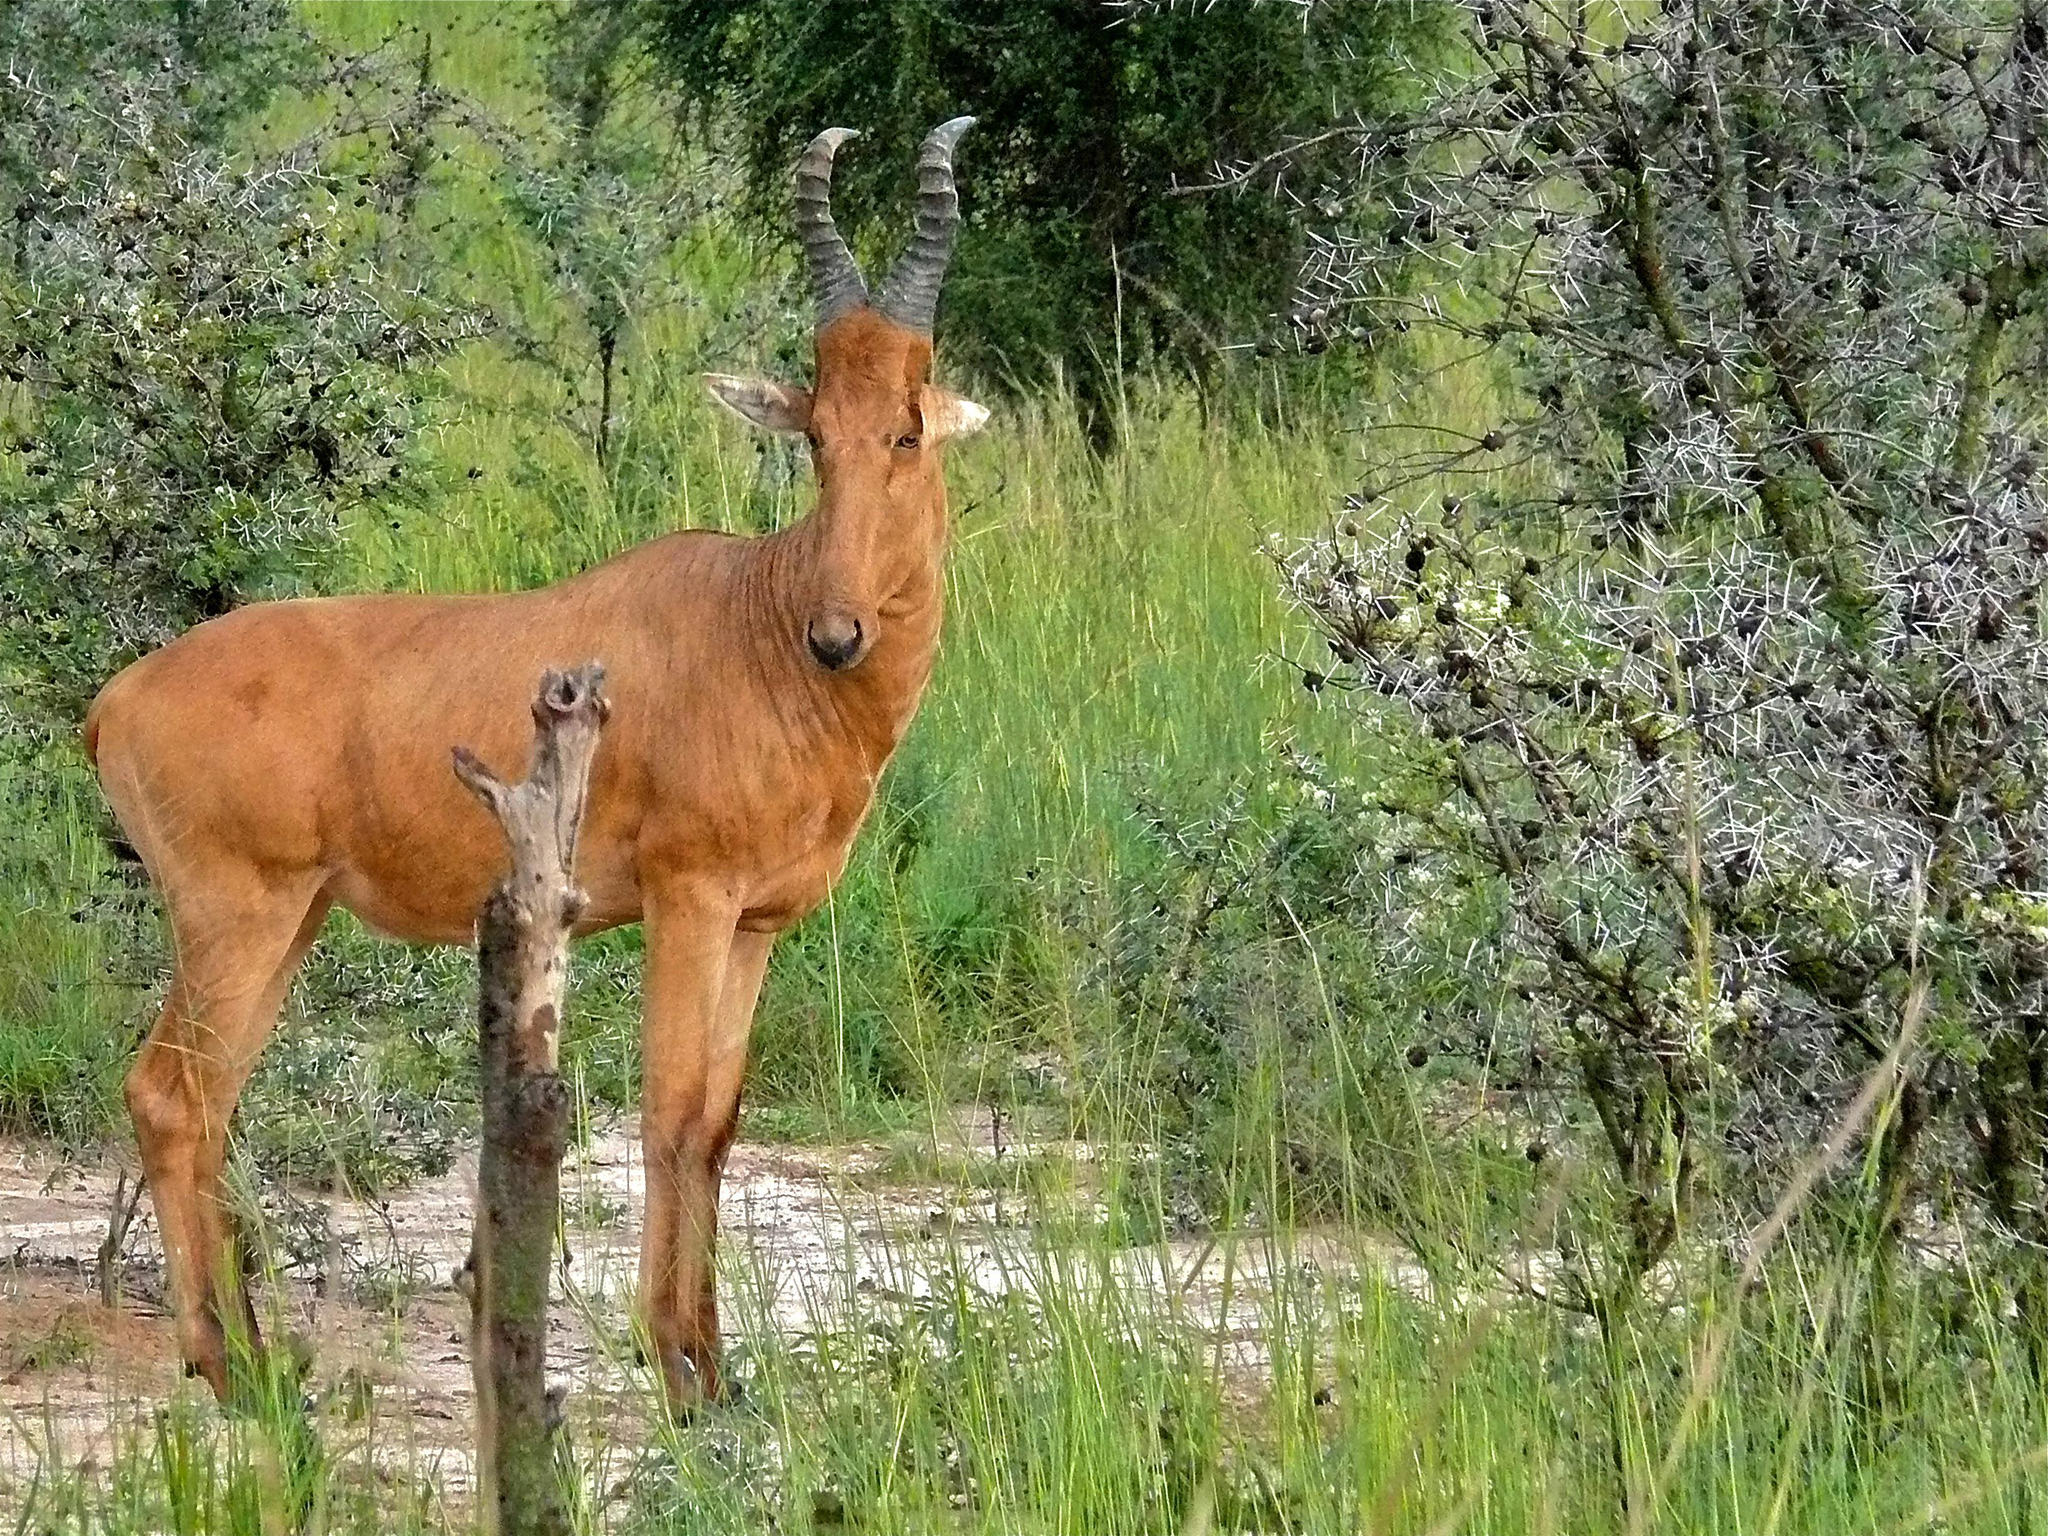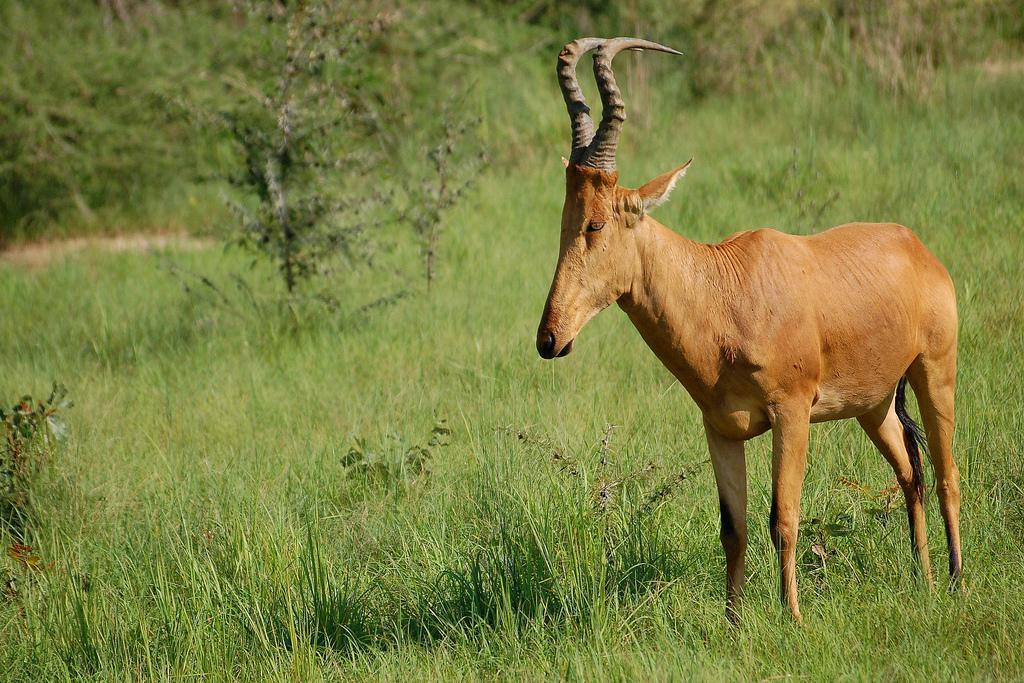The first image is the image on the left, the second image is the image on the right. Given the left and right images, does the statement "An image contains only one horned animal, which is standing with its head and body turned leftward." hold true? Answer yes or no. Yes. The first image is the image on the left, the second image is the image on the right. Evaluate the accuracy of this statement regarding the images: "Two antelopes are facing the opposite direction than the other.". Is it true? Answer yes or no. Yes. 